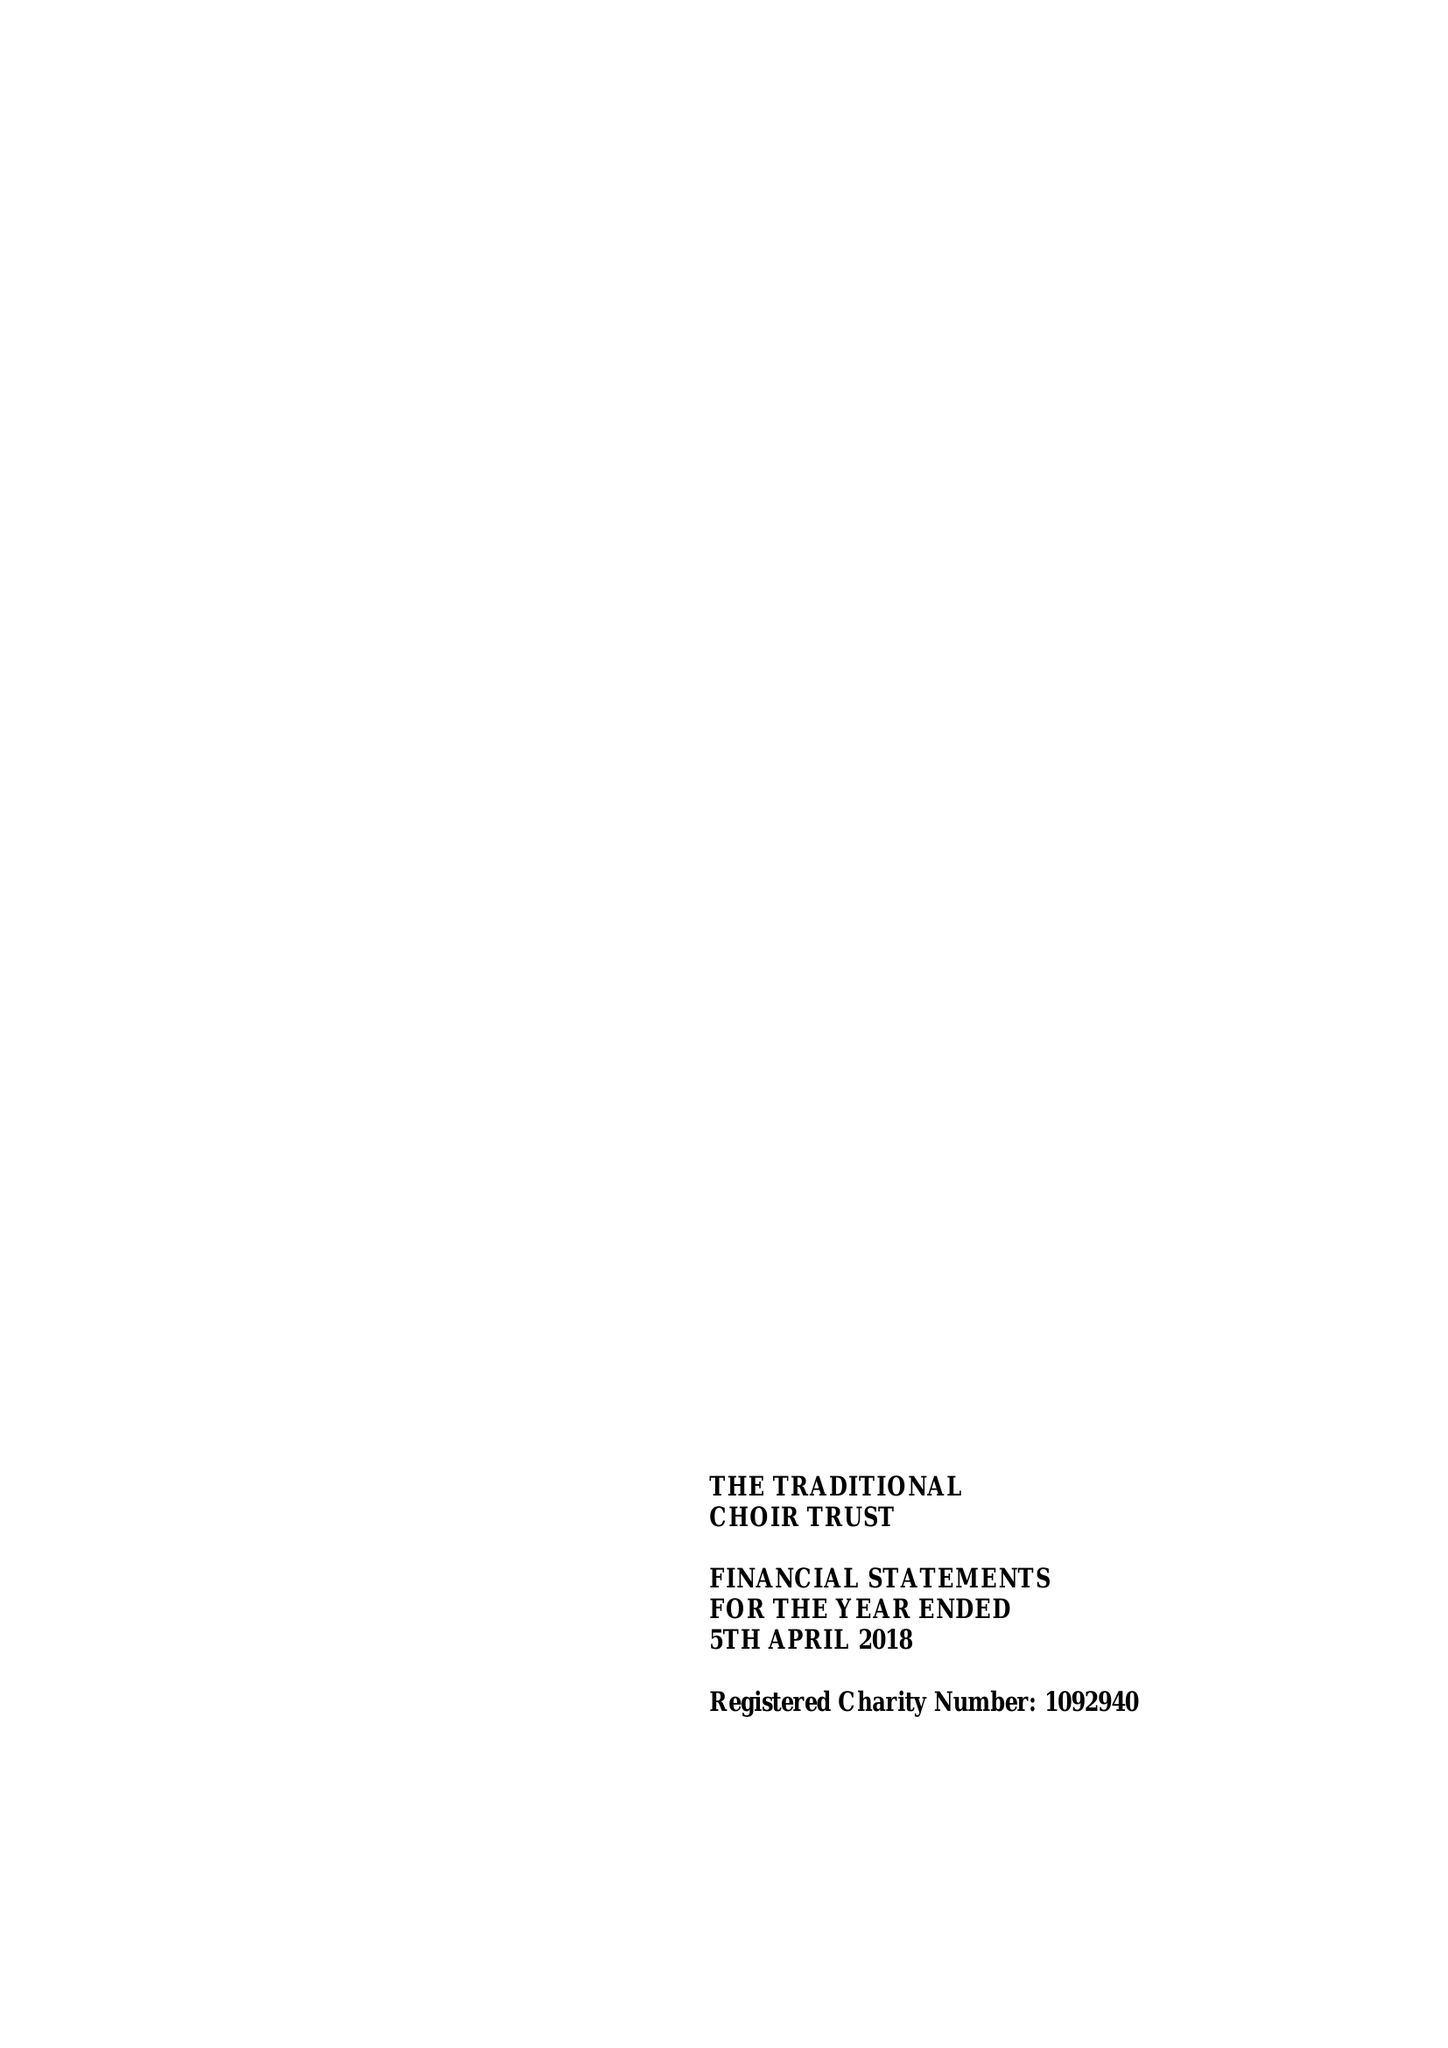What is the value for the address__street_line?
Answer the question using a single word or phrase. CANON LANE 